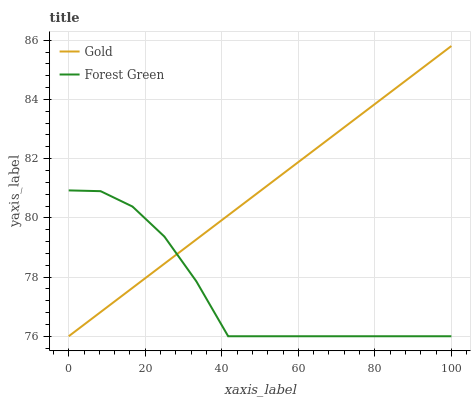Does Gold have the minimum area under the curve?
Answer yes or no. No. Is Gold the roughest?
Answer yes or no. No. 